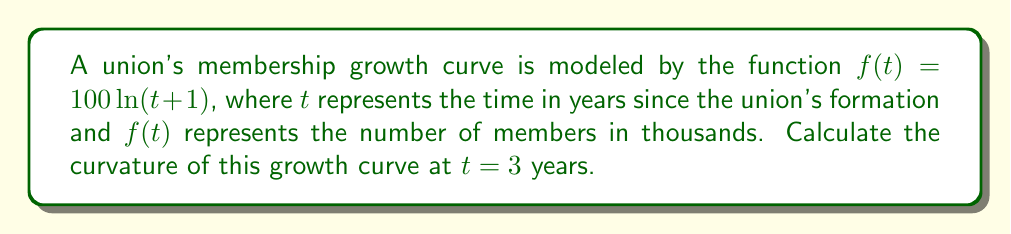Help me with this question. To determine the curvature of the union membership growth curve, we'll follow these steps:

1) The formula for curvature $\kappa$ of a function $y=f(x)$ is:

   $$\kappa = \frac{|f''(x)|}{(1 + [f'(x)]^2)^{3/2}}$$

2) First, let's find $f'(t)$ and $f''(t)$:
   
   $f'(t) = \frac{100}{t+1}$
   
   $f''(t) = -\frac{100}{(t+1)^2}$

3) Now, let's evaluate these at $t=3$:
   
   $f'(3) = \frac{100}{4} = 25$
   
   $f''(3) = -\frac{100}{16} = -6.25$

4) Substituting these values into the curvature formula:

   $$\kappa = \frac{|-6.25|}{(1 + 25^2)^{3/2}}$$

5) Simplify:
   
   $$\kappa = \frac{6.25}{(1 + 625)^{3/2}} = \frac{6.25}{626^{3/2}}$$

6) Calculate the final value:
   
   $$\kappa \approx 0.000399$$

This curvature value indicates how quickly the rate of union membership growth is changing at the 3-year mark, reflecting the real-world dynamics of union expansion over time.
Answer: $\kappa \approx 0.000399$ 